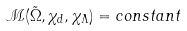Convert formula to latex. <formula><loc_0><loc_0><loc_500><loc_500>\mathcal { M } ( \tilde { \Omega } , \chi _ { d } , \chi _ { \Lambda } ) = c o n s t a n t</formula> 